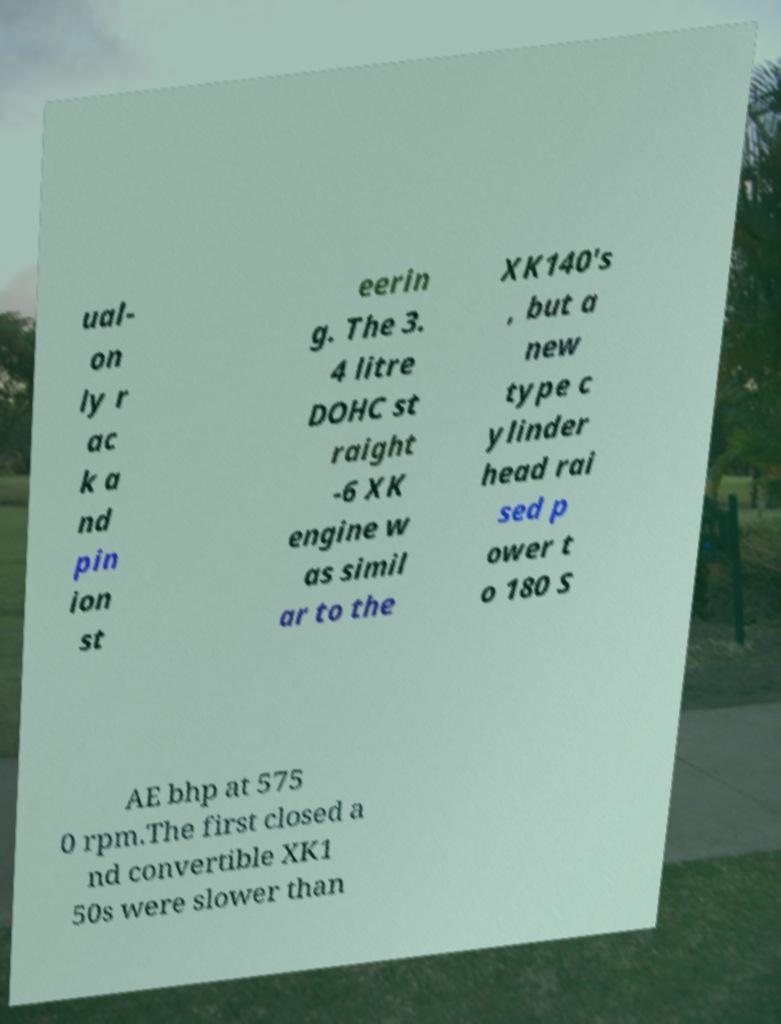I need the written content from this picture converted into text. Can you do that? ual- on ly r ac k a nd pin ion st eerin g. The 3. 4 litre DOHC st raight -6 XK engine w as simil ar to the XK140's , but a new type c ylinder head rai sed p ower t o 180 S AE bhp at 575 0 rpm.The first closed a nd convertible XK1 50s were slower than 